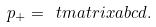Convert formula to latex. <formula><loc_0><loc_0><loc_500><loc_500>p _ { + } = \ t m a t r i x a b c d .</formula> 